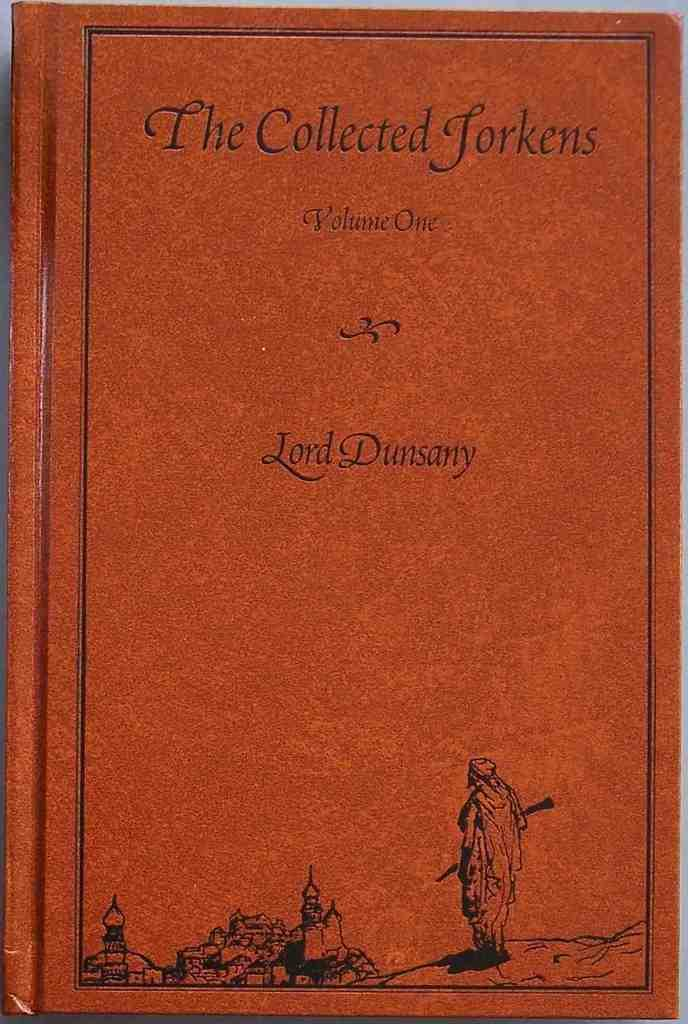<image>
Summarize the visual content of the image. Lord Dunsany's first volume has a red cover and small black figures at the bottom. 